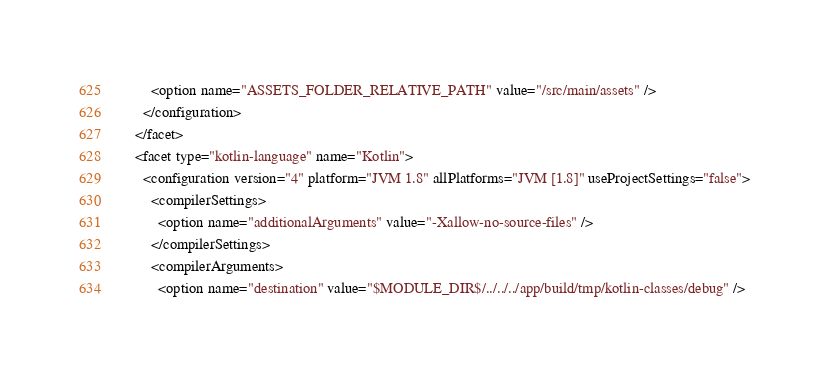Convert code to text. <code><loc_0><loc_0><loc_500><loc_500><_XML_>        <option name="ASSETS_FOLDER_RELATIVE_PATH" value="/src/main/assets" />
      </configuration>
    </facet>
    <facet type="kotlin-language" name="Kotlin">
      <configuration version="4" platform="JVM 1.8" allPlatforms="JVM [1.8]" useProjectSettings="false">
        <compilerSettings>
          <option name="additionalArguments" value="-Xallow-no-source-files" />
        </compilerSettings>
        <compilerArguments>
          <option name="destination" value="$MODULE_DIR$/../../../app/build/tmp/kotlin-classes/debug" /></code> 